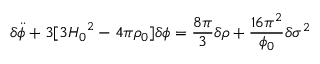<formula> <loc_0><loc_0><loc_500><loc_500>{ \delta } \ddot { \phi } + 3 [ 3 { H _ { 0 } } ^ { 2 } - 4 { \pi } { \rho } _ { 0 } ] { \delta } { \phi } = \frac { 8 { \pi } } { 3 } { \delta } { \rho } + \frac { 1 6 { \pi } ^ { 2 } } { { \phi } _ { 0 } } { \delta } { { \sigma } ^ { 2 } }</formula> 